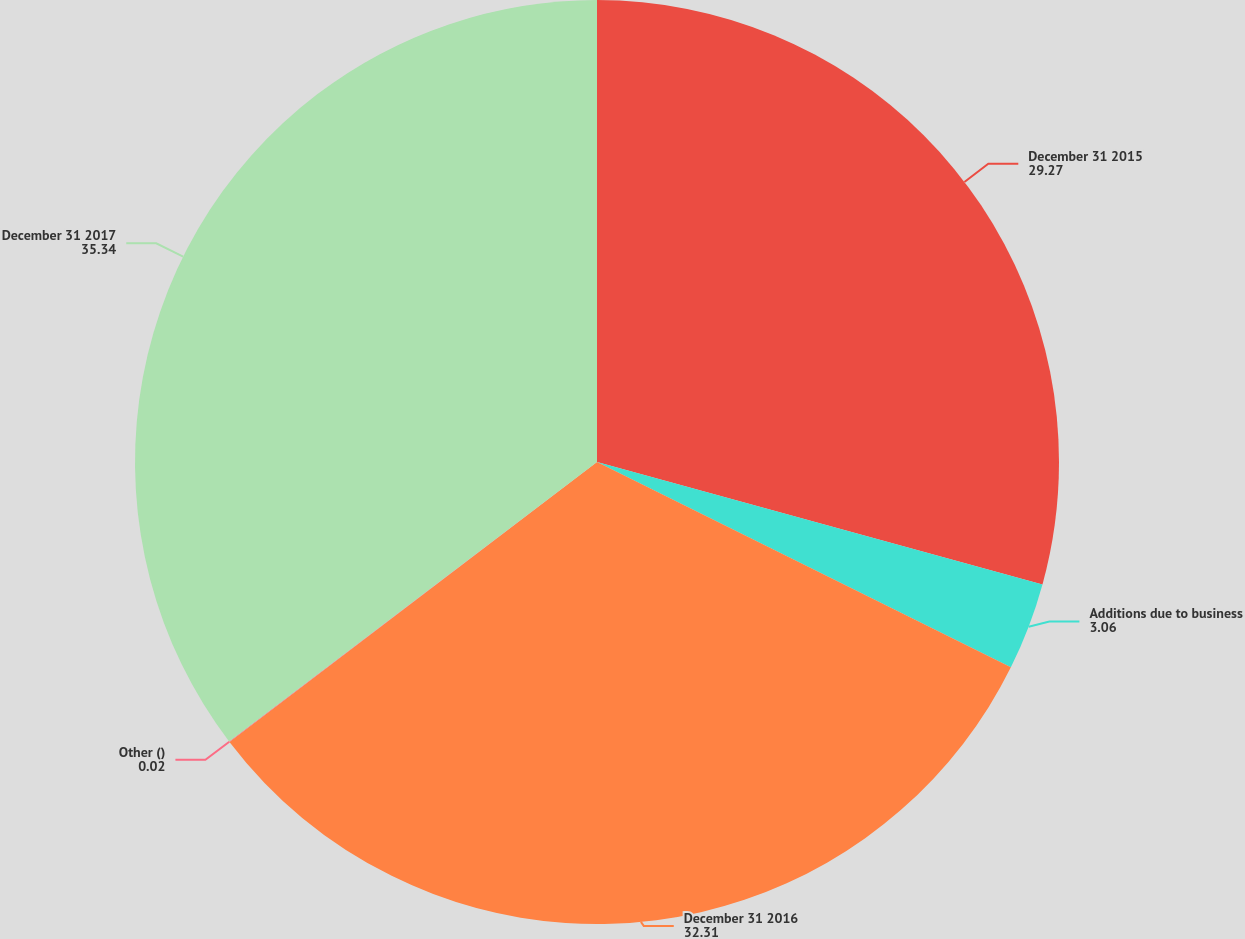Convert chart. <chart><loc_0><loc_0><loc_500><loc_500><pie_chart><fcel>December 31 2015<fcel>Additions due to business<fcel>December 31 2016<fcel>Other ()<fcel>December 31 2017<nl><fcel>29.27%<fcel>3.06%<fcel>32.31%<fcel>0.02%<fcel>35.34%<nl></chart> 